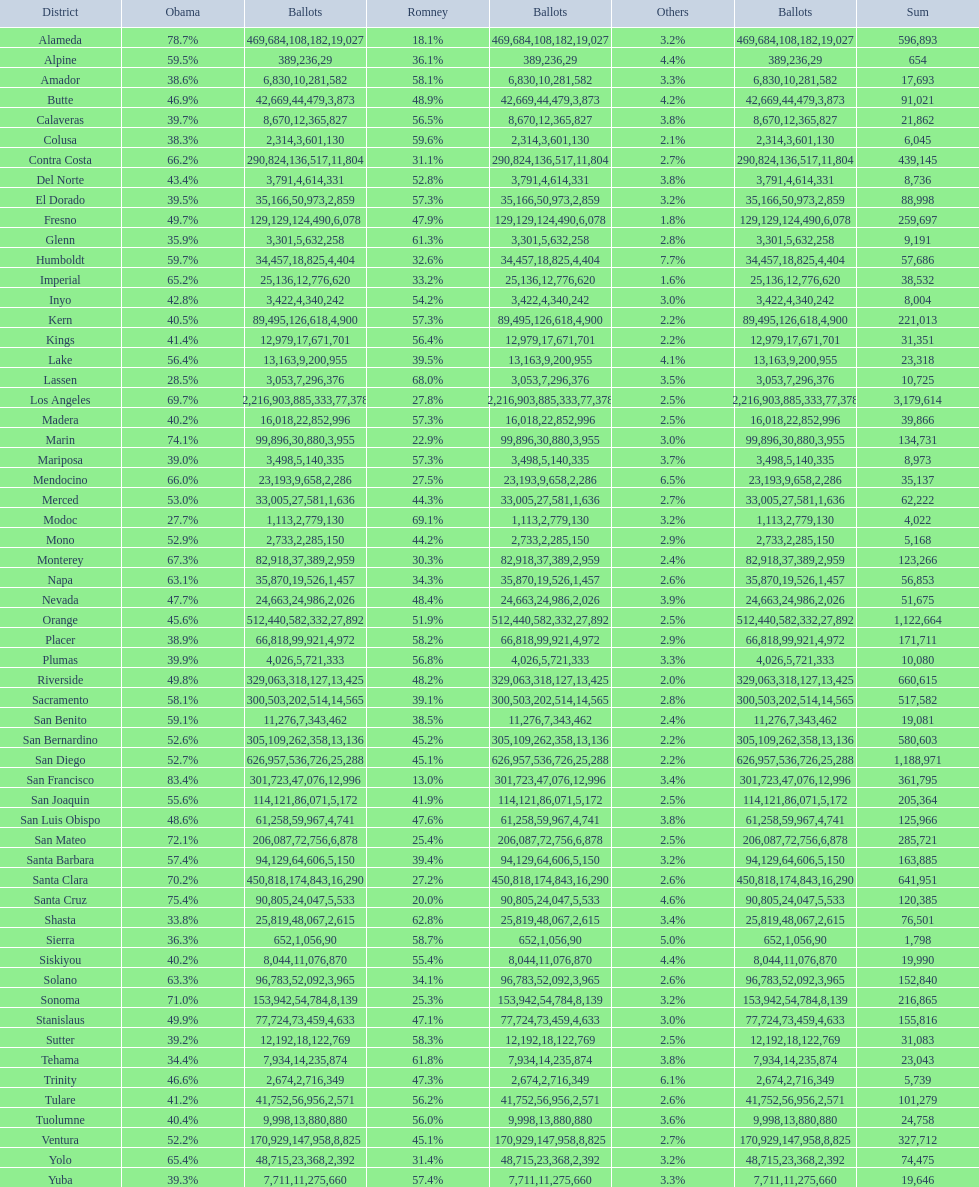In how many counties did obama receive a minimum of 75% of the votes? 3. 